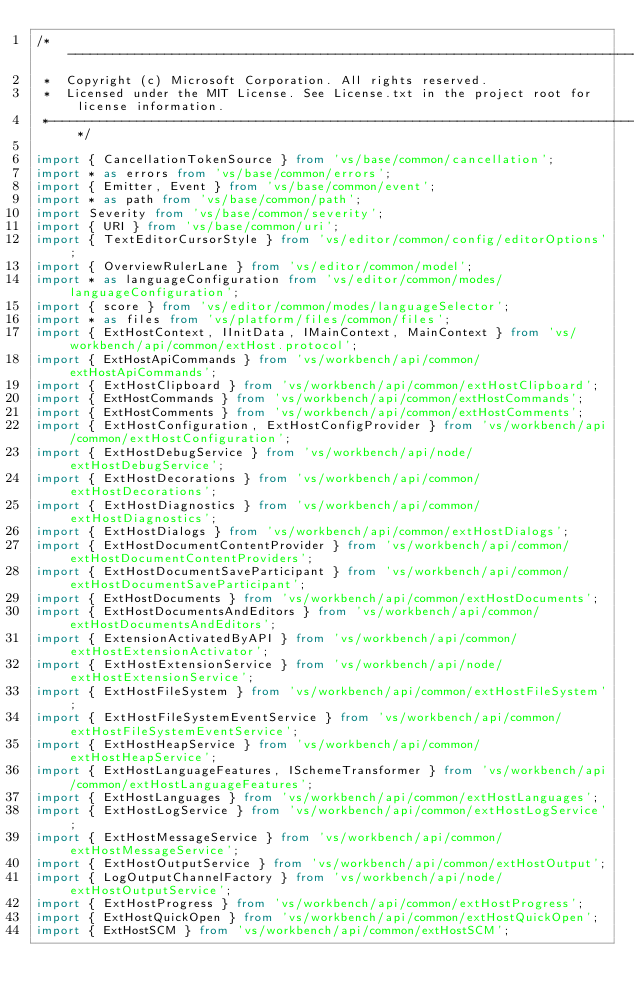Convert code to text. <code><loc_0><loc_0><loc_500><loc_500><_TypeScript_>/*---------------------------------------------------------------------------------------------
 *  Copyright (c) Microsoft Corporation. All rights reserved.
 *  Licensed under the MIT License. See License.txt in the project root for license information.
 *--------------------------------------------------------------------------------------------*/

import { CancellationTokenSource } from 'vs/base/common/cancellation';
import * as errors from 'vs/base/common/errors';
import { Emitter, Event } from 'vs/base/common/event';
import * as path from 'vs/base/common/path';
import Severity from 'vs/base/common/severity';
import { URI } from 'vs/base/common/uri';
import { TextEditorCursorStyle } from 'vs/editor/common/config/editorOptions';
import { OverviewRulerLane } from 'vs/editor/common/model';
import * as languageConfiguration from 'vs/editor/common/modes/languageConfiguration';
import { score } from 'vs/editor/common/modes/languageSelector';
import * as files from 'vs/platform/files/common/files';
import { ExtHostContext, IInitData, IMainContext, MainContext } from 'vs/workbench/api/common/extHost.protocol';
import { ExtHostApiCommands } from 'vs/workbench/api/common/extHostApiCommands';
import { ExtHostClipboard } from 'vs/workbench/api/common/extHostClipboard';
import { ExtHostCommands } from 'vs/workbench/api/common/extHostCommands';
import { ExtHostComments } from 'vs/workbench/api/common/extHostComments';
import { ExtHostConfiguration, ExtHostConfigProvider } from 'vs/workbench/api/common/extHostConfiguration';
import { ExtHostDebugService } from 'vs/workbench/api/node/extHostDebugService';
import { ExtHostDecorations } from 'vs/workbench/api/common/extHostDecorations';
import { ExtHostDiagnostics } from 'vs/workbench/api/common/extHostDiagnostics';
import { ExtHostDialogs } from 'vs/workbench/api/common/extHostDialogs';
import { ExtHostDocumentContentProvider } from 'vs/workbench/api/common/extHostDocumentContentProviders';
import { ExtHostDocumentSaveParticipant } from 'vs/workbench/api/common/extHostDocumentSaveParticipant';
import { ExtHostDocuments } from 'vs/workbench/api/common/extHostDocuments';
import { ExtHostDocumentsAndEditors } from 'vs/workbench/api/common/extHostDocumentsAndEditors';
import { ExtensionActivatedByAPI } from 'vs/workbench/api/common/extHostExtensionActivator';
import { ExtHostExtensionService } from 'vs/workbench/api/node/extHostExtensionService';
import { ExtHostFileSystem } from 'vs/workbench/api/common/extHostFileSystem';
import { ExtHostFileSystemEventService } from 'vs/workbench/api/common/extHostFileSystemEventService';
import { ExtHostHeapService } from 'vs/workbench/api/common/extHostHeapService';
import { ExtHostLanguageFeatures, ISchemeTransformer } from 'vs/workbench/api/common/extHostLanguageFeatures';
import { ExtHostLanguages } from 'vs/workbench/api/common/extHostLanguages';
import { ExtHostLogService } from 'vs/workbench/api/common/extHostLogService';
import { ExtHostMessageService } from 'vs/workbench/api/common/extHostMessageService';
import { ExtHostOutputService } from 'vs/workbench/api/common/extHostOutput';
import { LogOutputChannelFactory } from 'vs/workbench/api/node/extHostOutputService';
import { ExtHostProgress } from 'vs/workbench/api/common/extHostProgress';
import { ExtHostQuickOpen } from 'vs/workbench/api/common/extHostQuickOpen';
import { ExtHostSCM } from 'vs/workbench/api/common/extHostSCM';</code> 